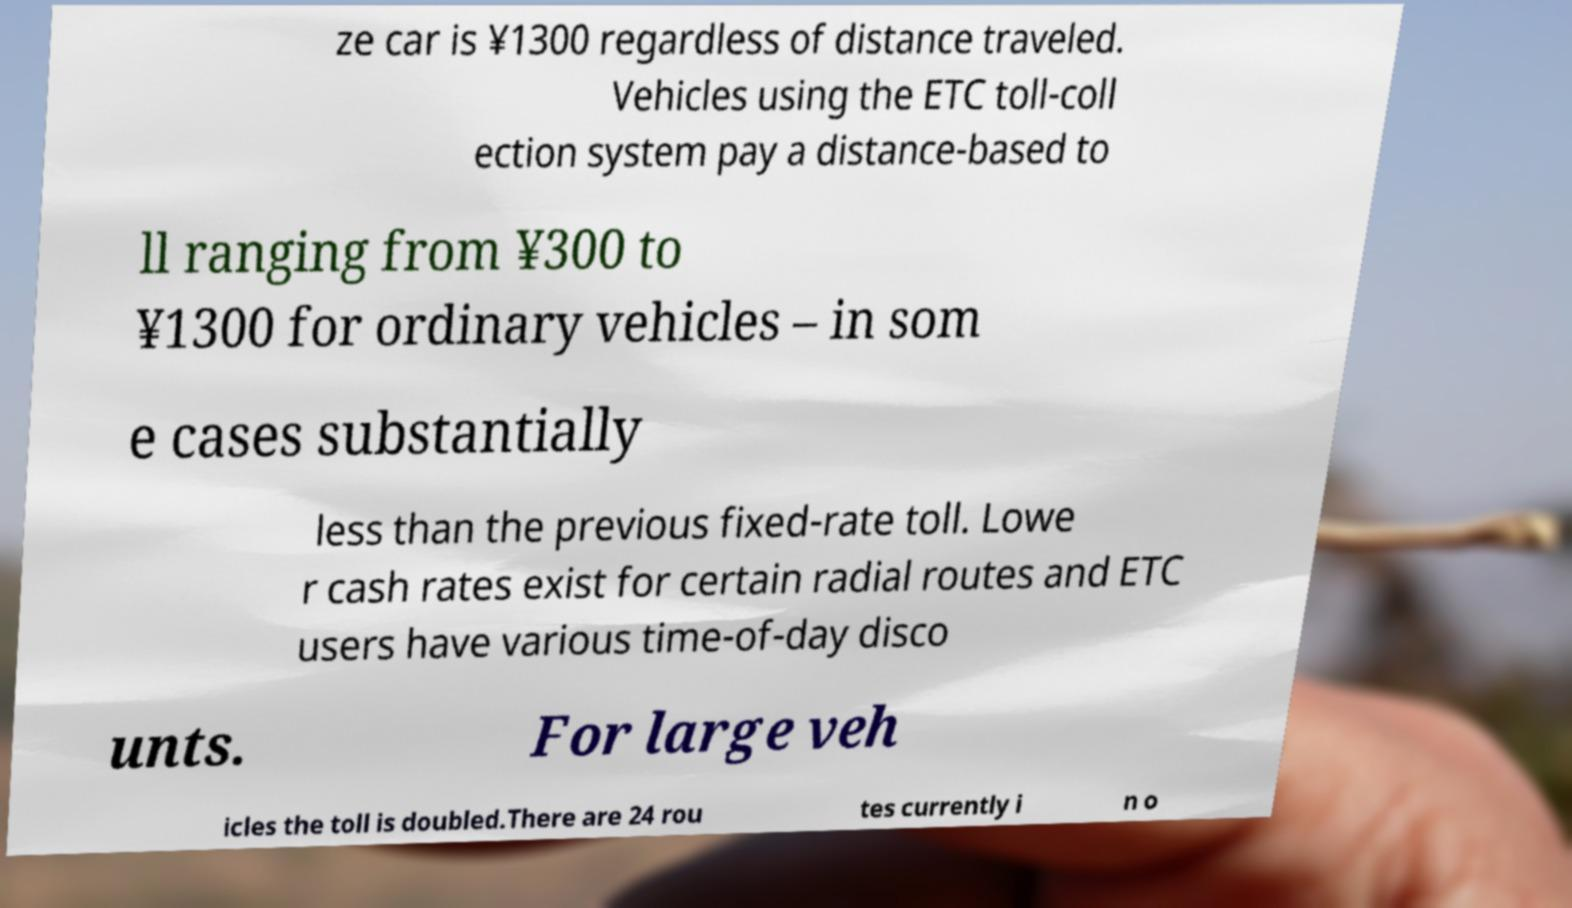I need the written content from this picture converted into text. Can you do that? ze car is ¥1300 regardless of distance traveled. Vehicles using the ETC toll-coll ection system pay a distance-based to ll ranging from ¥300 to ¥1300 for ordinary vehicles – in som e cases substantially less than the previous fixed-rate toll. Lowe r cash rates exist for certain radial routes and ETC users have various time-of-day disco unts. For large veh icles the toll is doubled.There are 24 rou tes currently i n o 